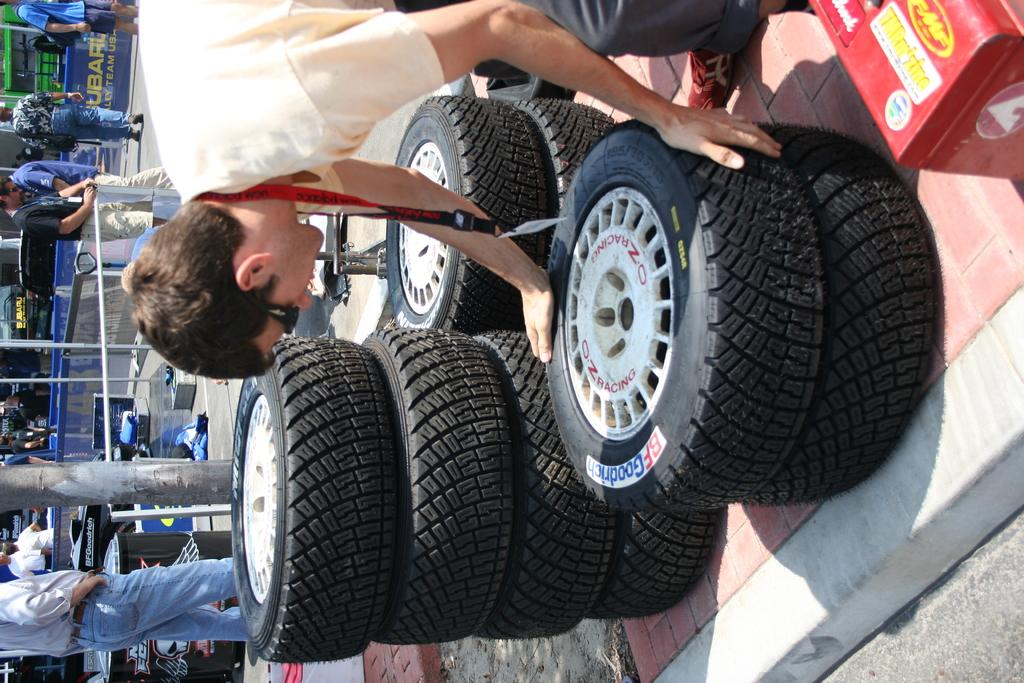What type of objects with circular shapes can be seen in the image? There are wheels in the image. Who or what is present in the image? There are people in the image. What kind of barrier can be seen in the image? There is a fence in the image. Can you describe any other objects visible in the image? There are some other objects in the image. What type of disease is being treated in the image? There is no indication of a disease or any medical treatment in the image. What color is the button on the person's shirt in the image? There is no button mentioned or visible in the image. 